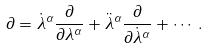<formula> <loc_0><loc_0><loc_500><loc_500>\partial = \dot { \lambda } ^ { \alpha } \frac { \partial } { \partial \lambda ^ { \alpha } } + \ddot { \lambda } ^ { \alpha } \frac { \partial } { \partial \dot { \lambda } ^ { \alpha } } + \cdots \, .</formula> 